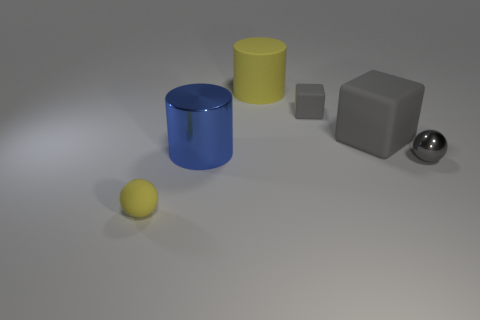Subtract 1 blocks. How many blocks are left? 1 Add 2 large objects. How many objects exist? 8 Subtract all blue cylinders. How many cylinders are left? 1 Subtract all cylinders. How many objects are left? 4 Add 2 large yellow objects. How many large yellow objects are left? 3 Add 3 gray blocks. How many gray blocks exist? 5 Subtract 0 purple balls. How many objects are left? 6 Subtract all red spheres. Subtract all yellow cylinders. How many spheres are left? 2 Subtract all big blue things. Subtract all blue things. How many objects are left? 4 